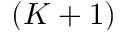Convert formula to latex. <formula><loc_0><loc_0><loc_500><loc_500>( K + 1 )</formula> 